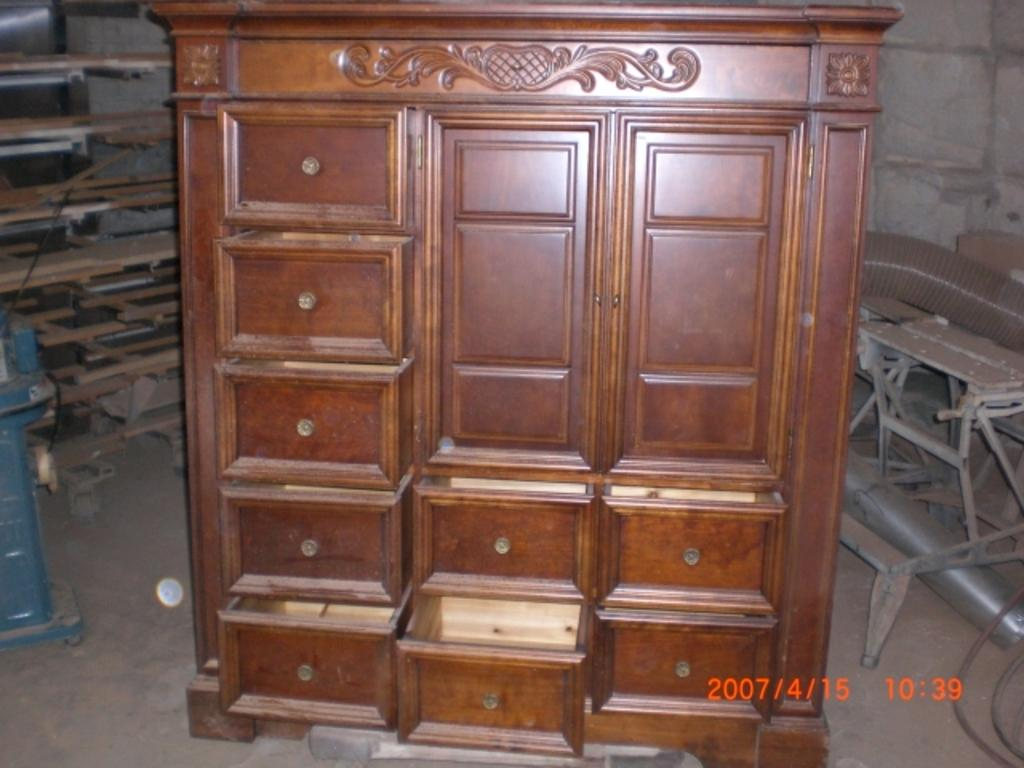What is the main object in the center of the image? There is a wooden cupboard in the center of the image. What can be seen behind the wooden cupboard? There is a wall in the background of the image. What is the surface on which the wooden cupboard is placed? There is a floor visible at the bottom of the image. What type of pipe can be seen running through the wooden cupboard in the image? There is no pipe visible in the image; it only features a wooden cupboard, a wall in the background, and a floor at the bottom. 